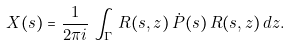<formula> <loc_0><loc_0><loc_500><loc_500>X ( s ) = \frac { 1 } { 2 \pi i } \, \int _ { \Gamma } \, R ( s , z ) \, \dot { P } ( s ) \, R ( s , z ) \, d z .</formula> 